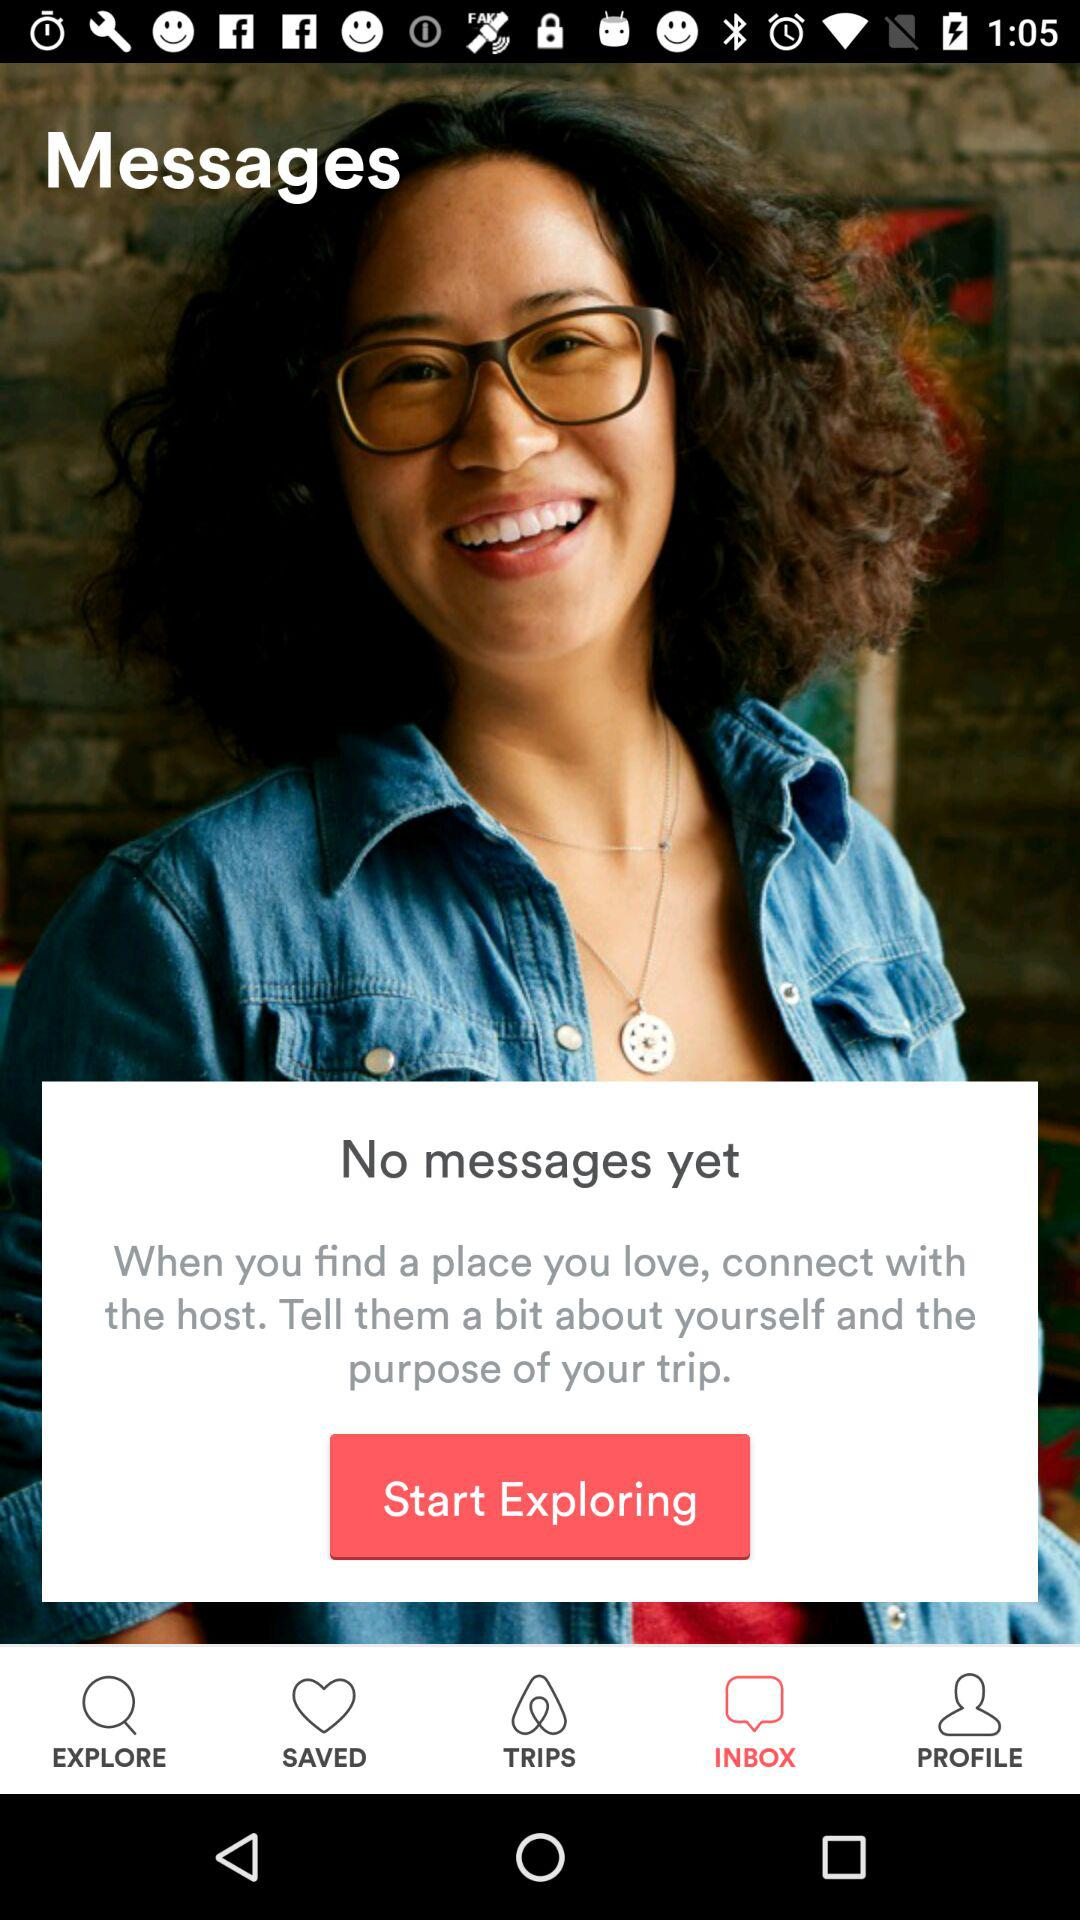How many messages do I have?
Answer the question using a single word or phrase. 0 